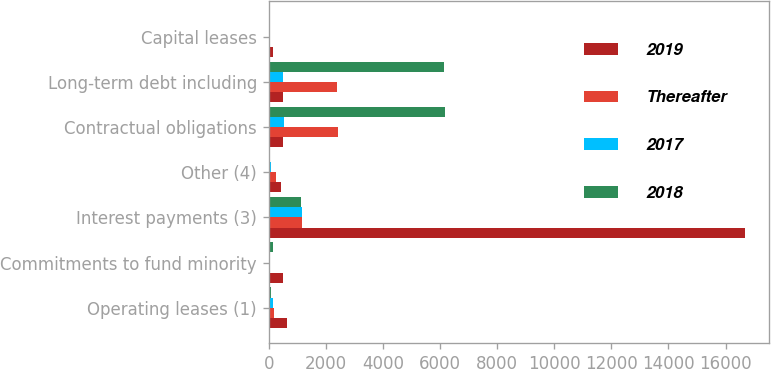Convert chart. <chart><loc_0><loc_0><loc_500><loc_500><stacked_bar_chart><ecel><fcel>Operating leases (1)<fcel>Commitments to fund minority<fcel>Interest payments (3)<fcel>Other (4)<fcel>Contractual obligations<fcel>Long-term debt including<fcel>Capital leases<nl><fcel>2019<fcel>624<fcel>494<fcel>16680<fcel>415<fcel>500<fcel>500<fcel>145<nl><fcel>Thereafter<fcel>196<fcel>58<fcel>1175<fcel>265<fcel>2419<fcel>2404<fcel>15<nl><fcel>2017<fcel>138<fcel>54<fcel>1156<fcel>63<fcel>538<fcel>506<fcel>32<nl><fcel>2018<fcel>93<fcel>144<fcel>1113<fcel>32<fcel>6173<fcel>6154<fcel>19<nl></chart> 